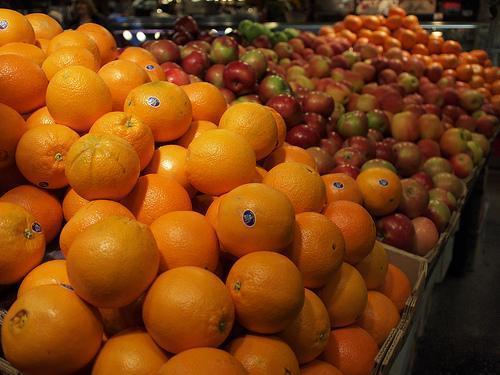How many oranges have stickers on them?
Give a very brief answer. 9. 